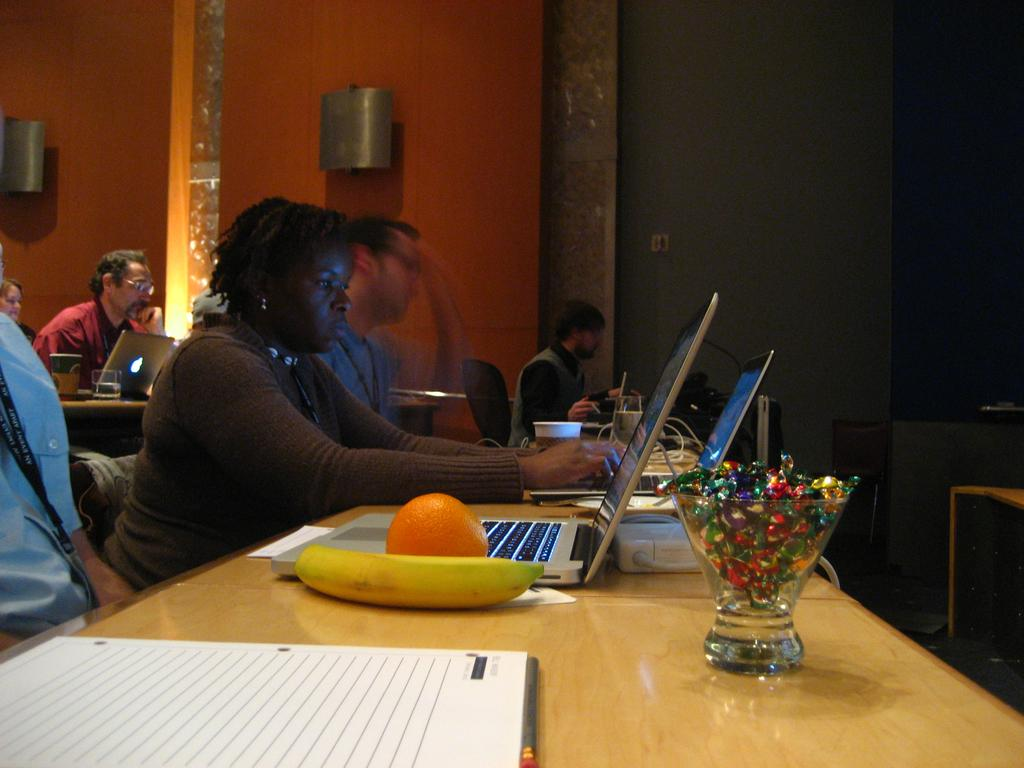What are the people in the image doing? The people in the image are sitting on chairs. What is present on the table in the image? There is a laptop and fruits on the table. Can you describe the table in the image? The table is a surface where the laptop and fruits are placed. Why are the people in the image crying? There is no indication in the image that the people are crying. 